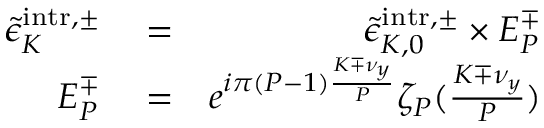<formula> <loc_0><loc_0><loc_500><loc_500>\begin{array} { r l r } { \tilde { \epsilon } _ { K } ^ { i n t r , \pm } } & = } & { \tilde { \epsilon } _ { K , 0 } ^ { i n t r , \pm } \times E _ { P } ^ { \mp } } \\ { E _ { P } ^ { \mp } } & = } & { e ^ { i \pi ( P - 1 ) \frac { K \mp \nu _ { y } } { P } } \zeta _ { P } ( \frac { K \mp \nu _ { y } } { P } ) } \end{array}</formula> 